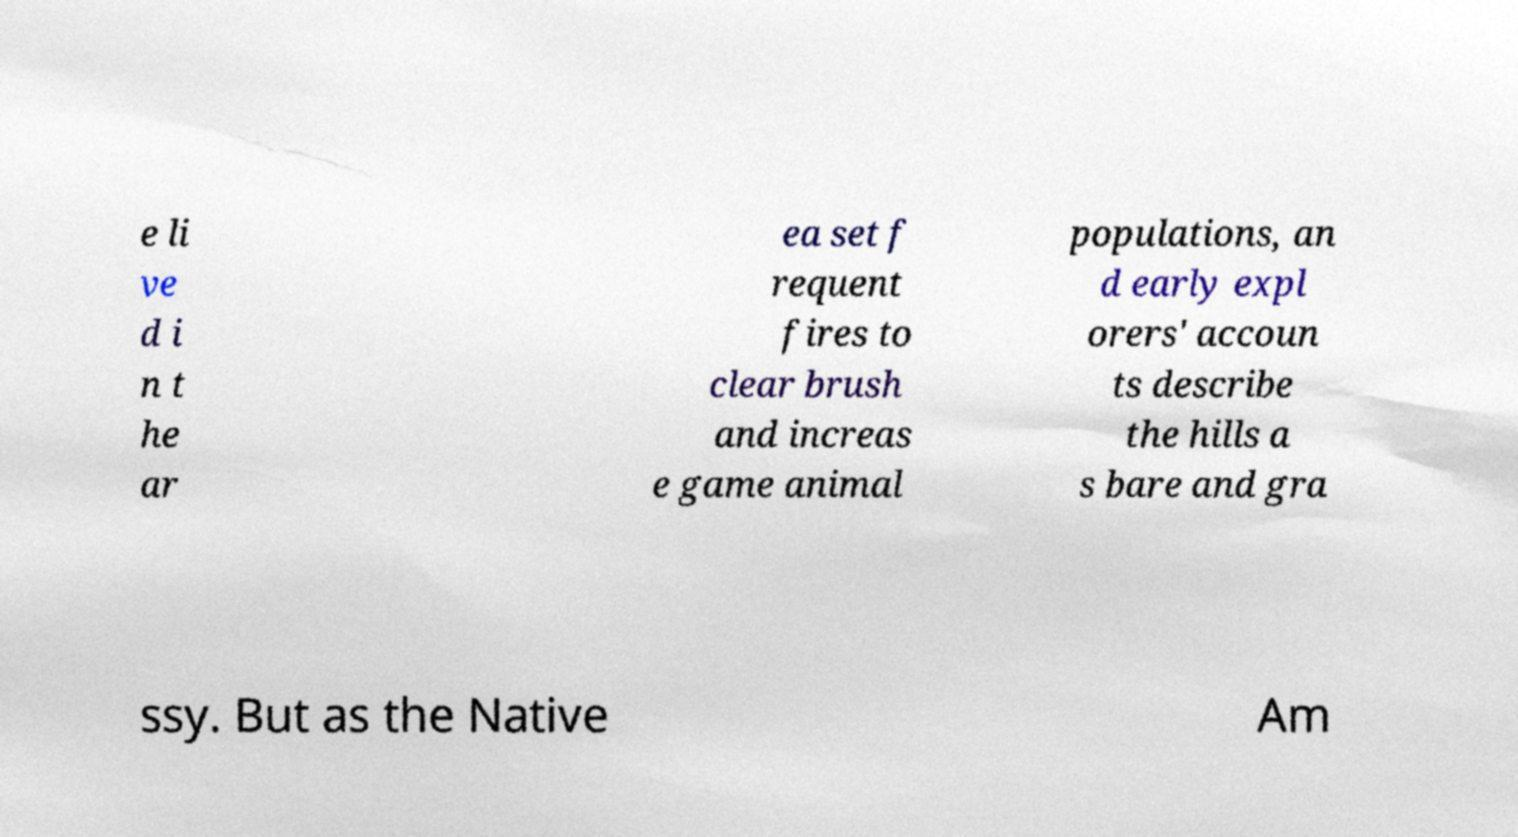Can you read and provide the text displayed in the image?This photo seems to have some interesting text. Can you extract and type it out for me? e li ve d i n t he ar ea set f requent fires to clear brush and increas e game animal populations, an d early expl orers' accoun ts describe the hills a s bare and gra ssy. But as the Native Am 